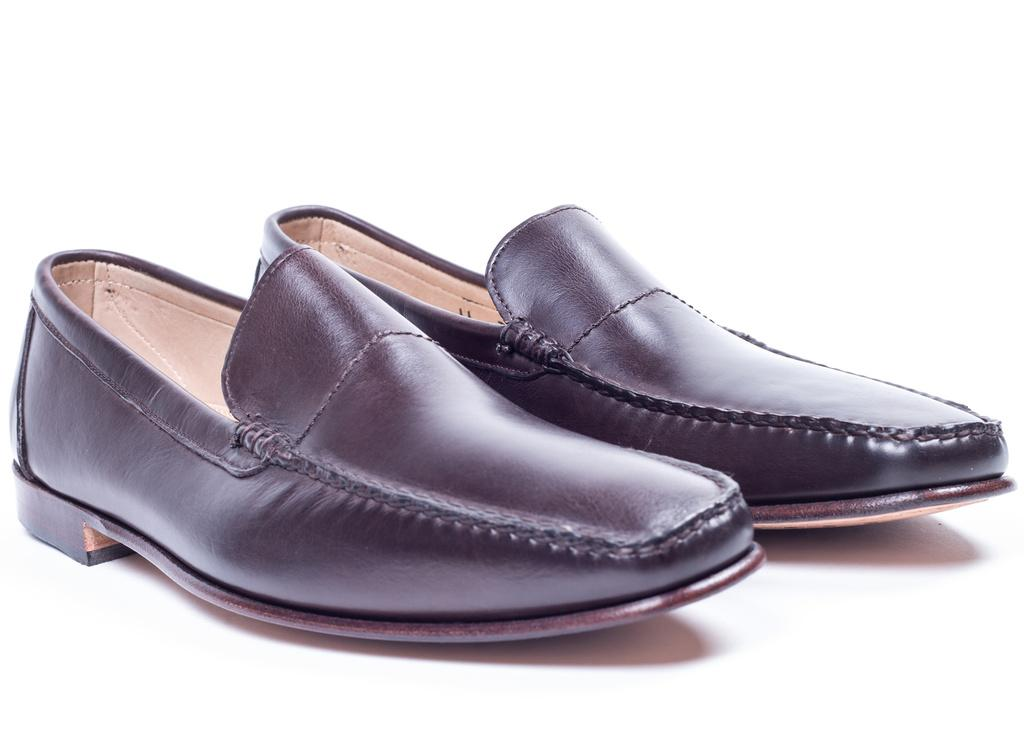What type of objects can be seen in the image? There are shoes in the image. How many jellyfish are swimming in the image? There are no jellyfish present in the image; it features shoes. What type of utensil is being used to water the plants in the image? There are no plants or watering utensils present in the image; it features shoes. 